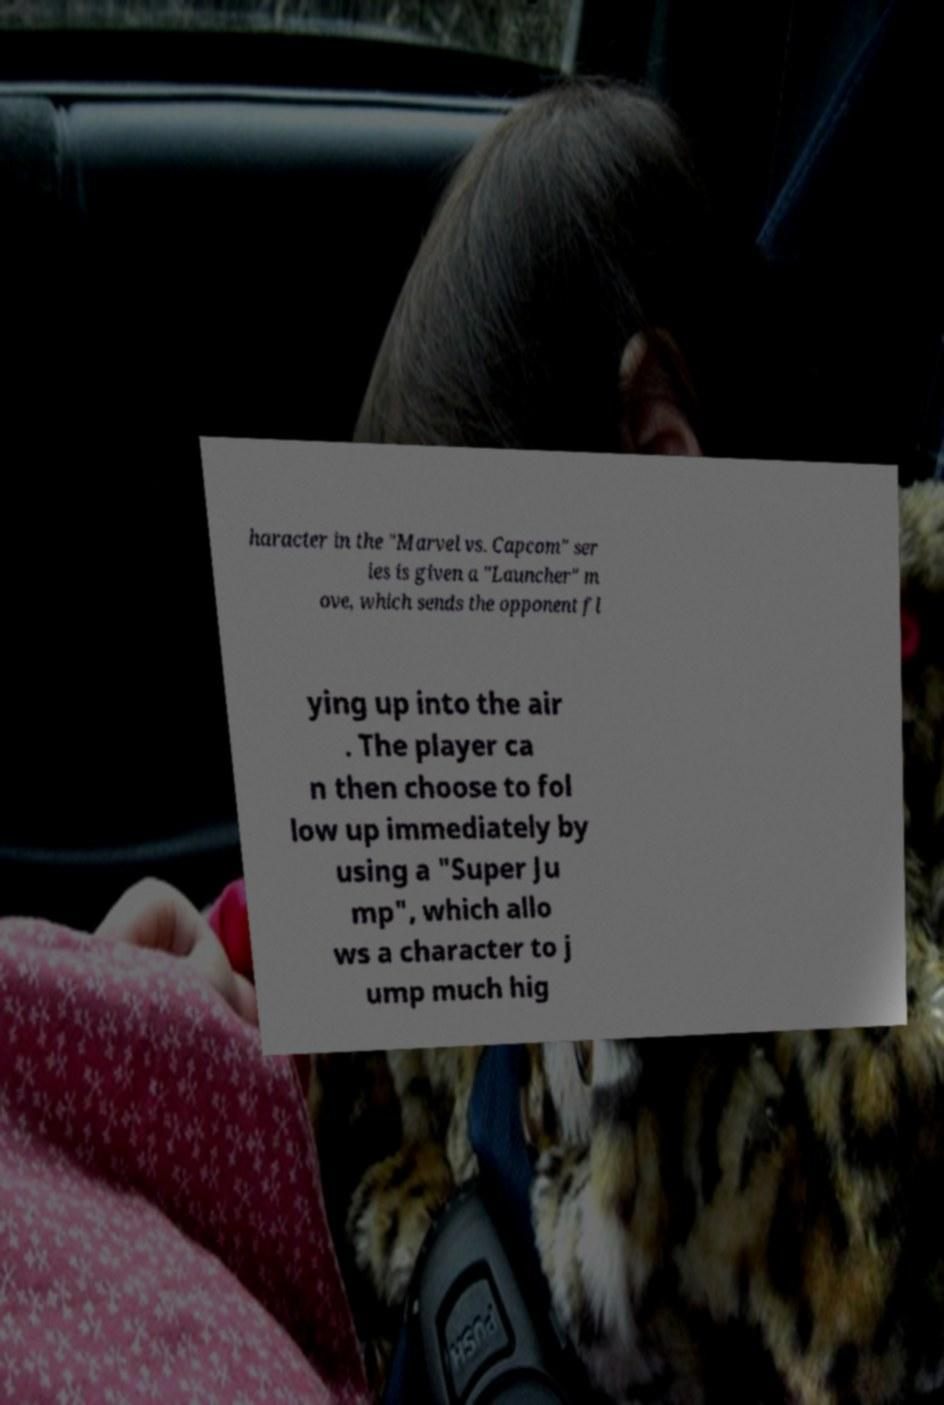I need the written content from this picture converted into text. Can you do that? haracter in the "Marvel vs. Capcom" ser ies is given a "Launcher" m ove, which sends the opponent fl ying up into the air . The player ca n then choose to fol low up immediately by using a "Super Ju mp", which allo ws a character to j ump much hig 